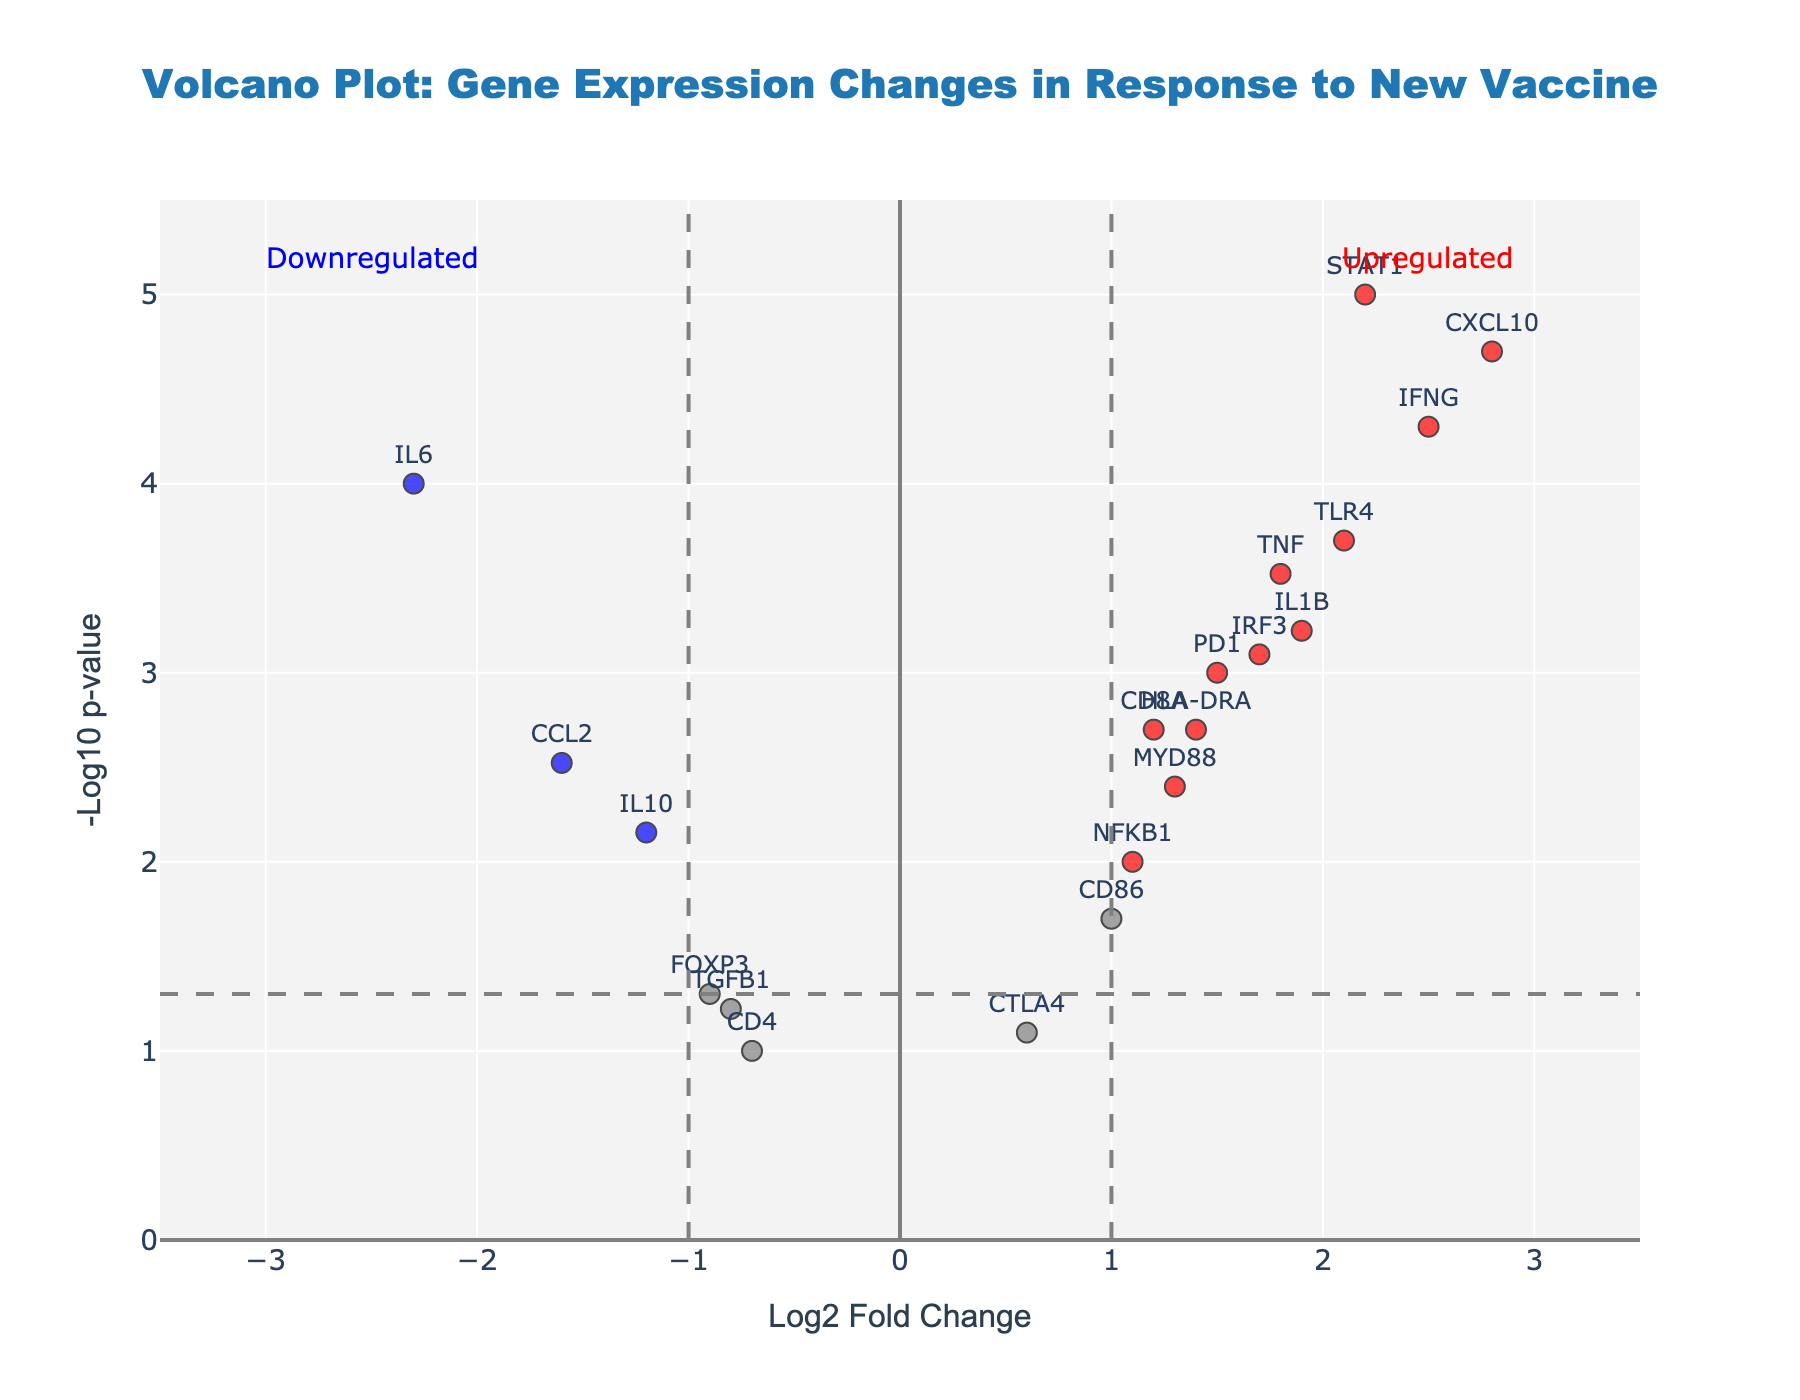What does the title of the plot indicate? The title is "Volcano Plot: Gene Expression Changes in Response to New Vaccine." It indicates that the plot shows how the expression levels of various genes have changed in response to a new vaccine.
Answer: Gene expression changes due to a new vaccine What does the x-axis represent? The x-axis is labeled "Log2 Fold Change." It represents the log2-transformed fold changes in gene expression levels between treated and control conditions.
Answer: Log2 Fold Change What does the y-axis represent? The y-axis is labeled "-Log10 p-value." It represents the -log10-transformed p-values of the statistical tests for gene expression changes.
Answer: -Log10 p-value How many genes are significantly upregulated based on the plot? The red points represent significantly upregulated genes, determined by both fold change and p-value thresholds. Count the red points on the right side of the y-axis threshold.
Answer: 9 Which gene shows the highest fold change? The gene farthest to the left or right on the x-axis will have the highest fold change. In this case, CXCL10 has the highest log2 fold change.
Answer: CXCL10 What is the significance threshold for p-value in this plot? The horizontal dashed line represents the p-value threshold. It appears at -log10(0.05).
Answer: 0.05 How many genes are significantly downregulated based on the plot? The blue points represent significantly downregulated genes, determined by both fold change and p-value thresholds. Count the blue points on the left side of the y-axis threshold.
Answer: 1 Which gene has the highest statistical significance? The gene farthest up on the y-axis has the lowest p-value (highest -log10 p-value). STAT1 is the gene with the highest significance.
Answer: STAT1 What are the colors used in the plot, and what do they represent? The colors used are red, blue, and gray. Red represents significantly upregulated genes, blue represents significantly downregulated genes, and gray represents non-significant genes.
Answer: red, blue, gray Which genes have a log2 fold change greater than 2? Examine the genes to the far right of the x-axis where the log2 fold change is greater than 2. IFNG, STAT1, and CXCL10 are the genes that meet this criterion.
Answer: IFNG, STAT1, CXCL10 